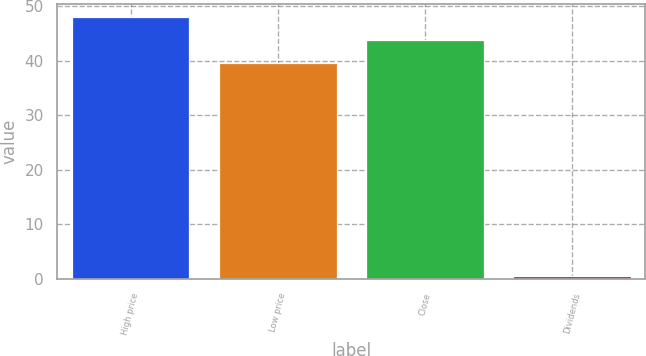<chart> <loc_0><loc_0><loc_500><loc_500><bar_chart><fcel>High price<fcel>Low price<fcel>Close<fcel>Dividends<nl><fcel>48.01<fcel>39.53<fcel>43.77<fcel>0.53<nl></chart> 